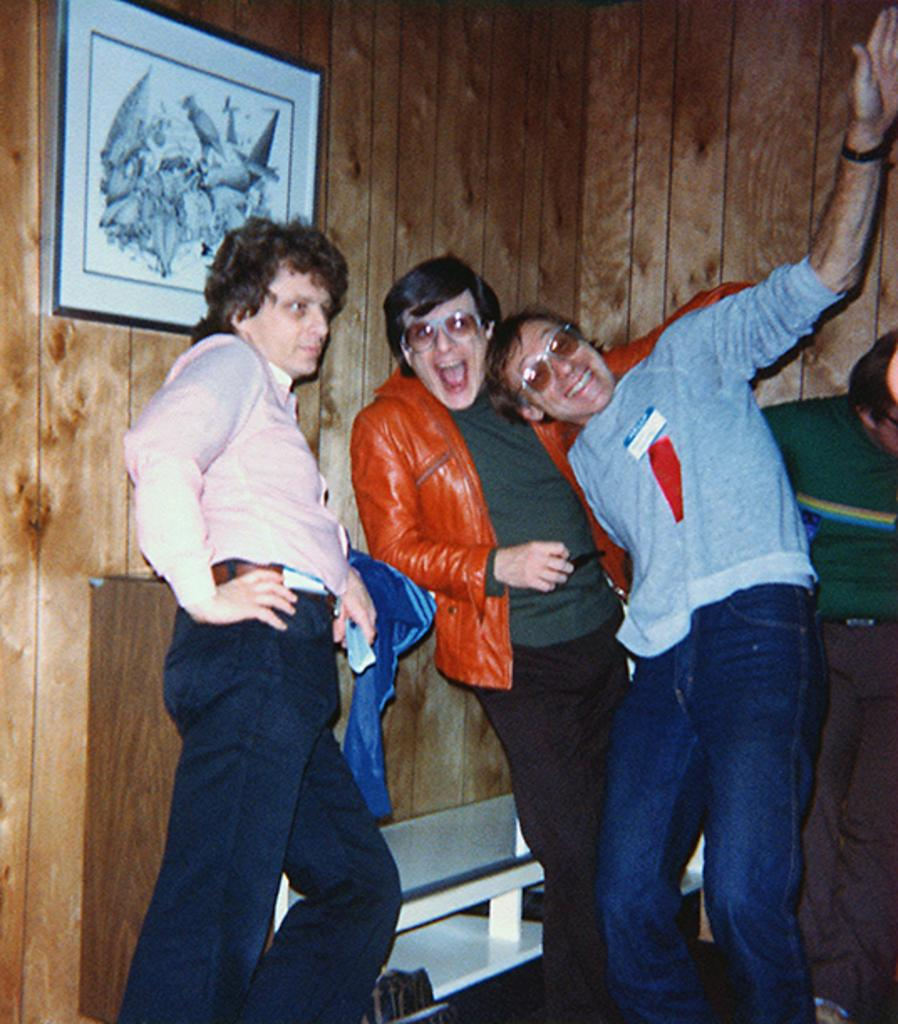How many people are present in the image? There are four persons standing in the image. Can you describe the background of the image? There is a wooden wall visible in the image, with a photo frame attached to it in the left top corner. What type of ball are the giants playing with in the image? There are no giants or balls present in the image. Who is the friend standing next to the person on the right in the image? The provided facts do not mention any friends or relationships between the persons in the image. 